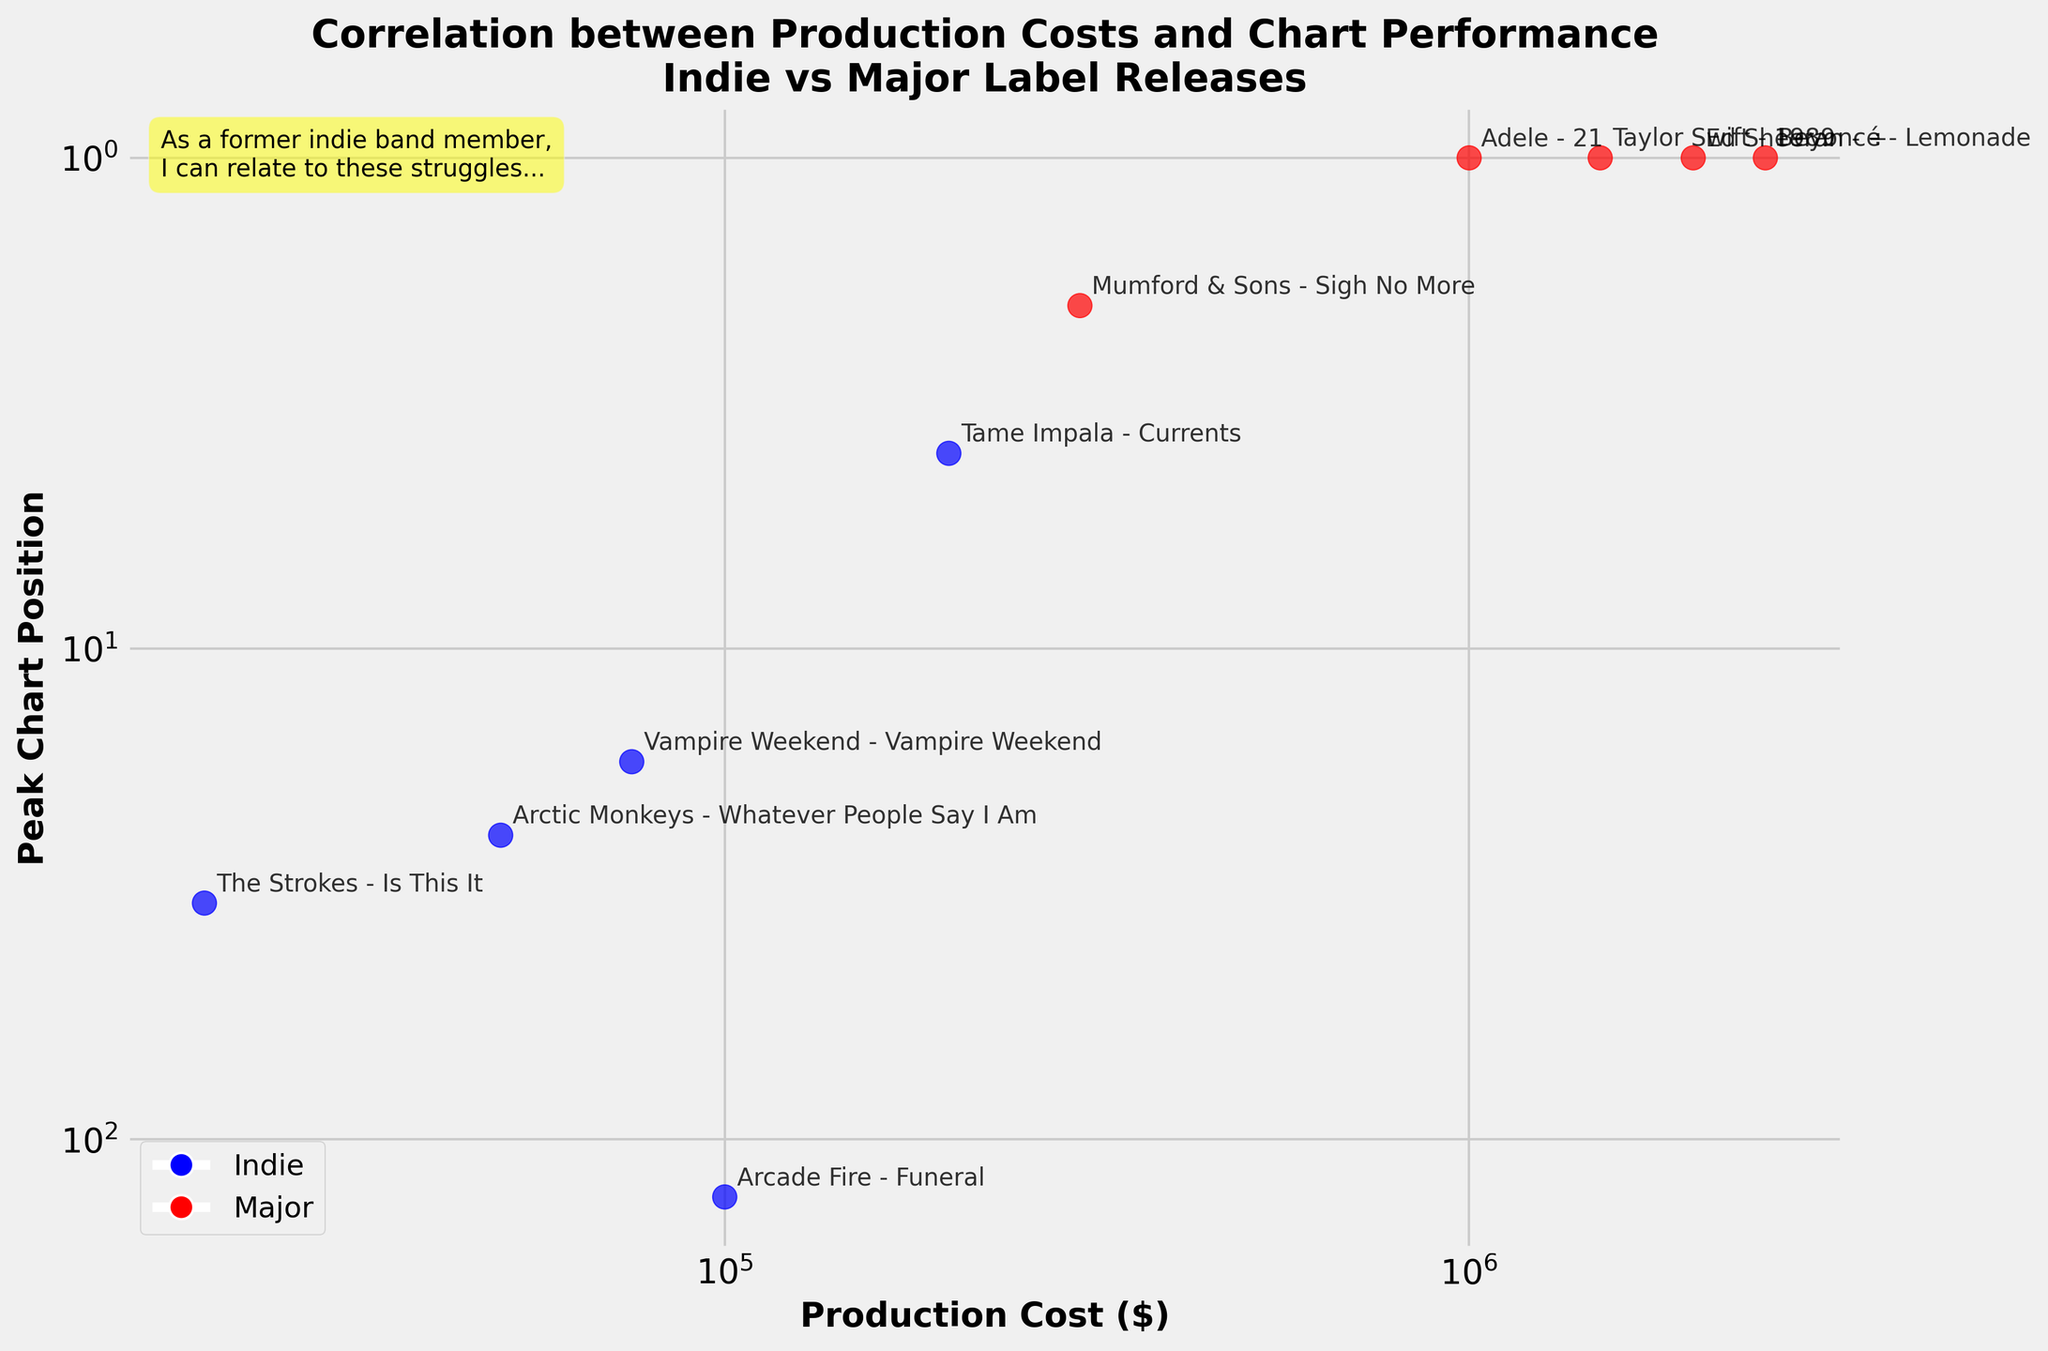How many albums are released by indie labels? Count the number of blue points representing indie labels in the scatter plot. There are 5 blue points, each representing an indie label release.
Answer: 5 Which album had the highest production cost among major label releases? Identify red points which represent major label releases. The point with the highest x-coordinate among the red points represents the highest production cost, which is 'Beyoncé - Lemonade' with a production cost of $2,500,000.
Answer: Beyoncé - Lemonade Which indie album has the best chart performance? Look for the blue points (indie releases) and find the one with the lowest y-value since lower values on the y-axis, which is inverted, indicate better chart positions. This album is 'Tame Impala - Currents' with a peak chart position of 4.
Answer: Tame Impala - Currents What is the peak chart position of 'Arcade Fire - Funeral'? Find the labeled point 'Arcade Fire - Funeral' and note the y-value corresponding to this point. The peak chart position for 'Arcade Fire - Funeral' is 131.
Answer: 131 What is the general trend between production costs and chart performance for major label releases? Observe the red points. They generally show that higher production costs correspond to better (lower) peak chart positions.
Answer: Higher costs, better chart positions What is the difference in production cost between 'The Strokes - Is This It' and 'Taylor Swift - 1989'? 'The Strokes - Is This It' has a production cost of $20,000, and 'Taylor Swift - 1989' has a production cost of $1,500,000. The difference is $1,500,000 - $20,000 = $1,480,000.
Answer: $1,480,000 Which label type has more albums with a peak chart position below 10? Identify points below the y-value of 10. They are 'Tame Impala - Currents' (Indie), 'Mumford & Sons - Sigh No More', 'Adele - 21', 'Taylor Swift - 1989', 'Ed Sheeran - ÷', 'Beyoncé - Lemonade' (Major). There is 1 indie and 5 major.
Answer: Major What is the median production cost of major label releases? List the production costs of major label releases: $300,000, $1,000,000, $1,500,000, $2,000,000, $2,500,000. The median value is the middle value when sorted, which is $1,500,000.
Answer: $1,500,000 Is there any case where lower production cost led to a better chart position? Comparing 'Tame Impala - Currents' (production cost: $200,000, chart position: 4) to all major releases with higher production costs but not better chart position (e.g., 'Mumford & Sons - Sigh No More' with $300,000, chart position: 2), confirms one such case.
Answer: Yes 